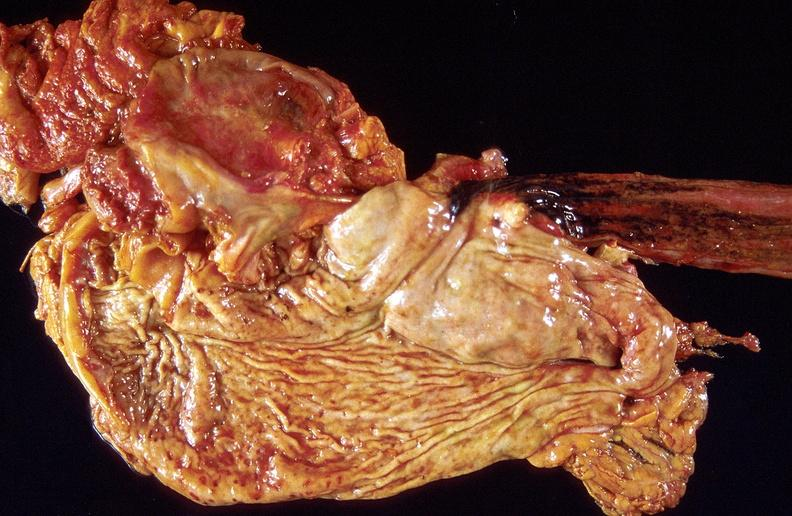does this image show stress ulcers, stomach?
Answer the question using a single word or phrase. Yes 